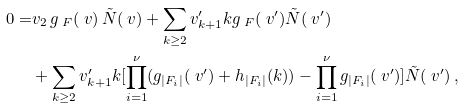<formula> <loc_0><loc_0><loc_500><loc_500>0 = & v _ { 2 } \, g _ { \ F } ( \ v ) \, \tilde { N } ( \ v ) + \sum _ { k \geq 2 } v ^ { \prime } _ { k + 1 } k g _ { \ F } ( \ v ^ { \prime } ) \tilde { N } ( \ v ^ { \prime } ) \\ & + \sum _ { k \geq 2 } v ^ { \prime } _ { k + 1 } k [ \prod _ { i = 1 } ^ { \nu } ( g _ { | F _ { i } | } ( \ v ^ { \prime } ) + h _ { | F _ { i } | } ( k ) ) - \prod _ { i = 1 } ^ { \nu } g _ { | F _ { i } | } ( \ v ^ { \prime } ) ] \tilde { N } ( \ v ^ { \prime } ) \, ,</formula> 